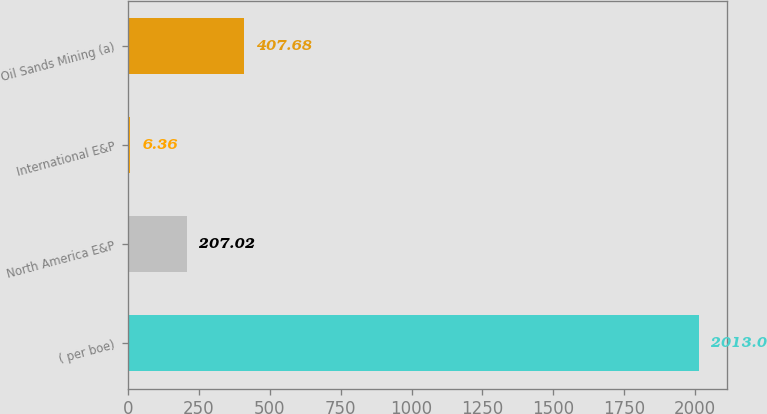Convert chart to OTSL. <chart><loc_0><loc_0><loc_500><loc_500><bar_chart><fcel>( per boe)<fcel>North America E&P<fcel>International E&P<fcel>Oil Sands Mining (a)<nl><fcel>2013<fcel>207.02<fcel>6.36<fcel>407.68<nl></chart> 